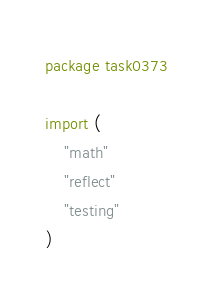Convert code to text. <code><loc_0><loc_0><loc_500><loc_500><_Go_>package task0373

import (
	"math"
	"reflect"
	"testing"
)
</code> 